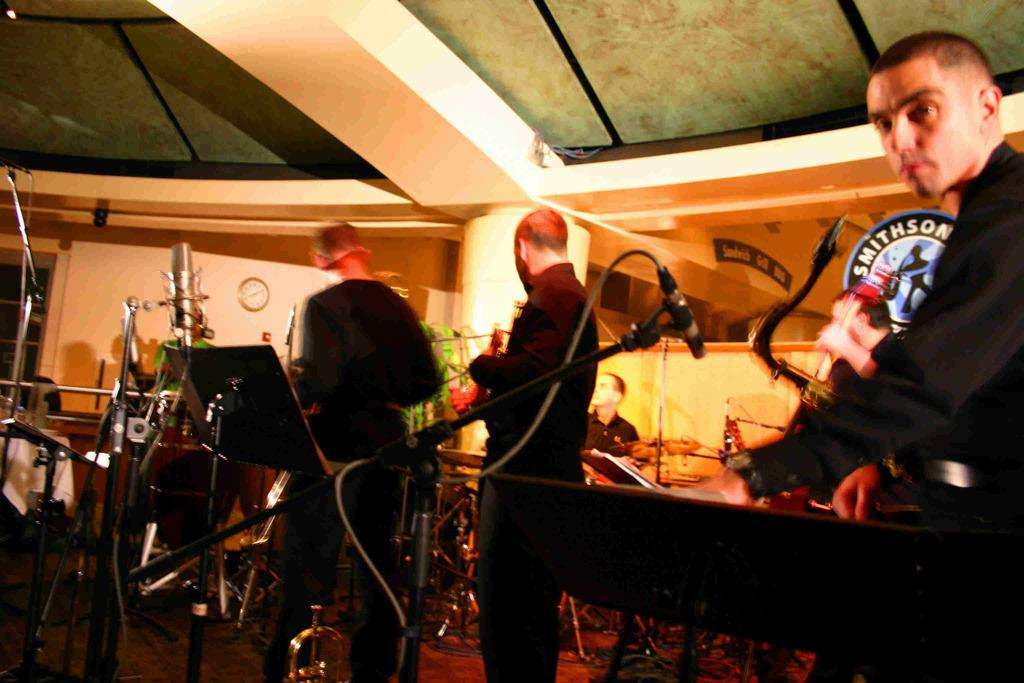What type of structure can be seen in the image? There is a wall in the image. What object is used for measuring time in the image? There is a clock in the image. What device is used for recording audio in the image? There is a mic in the image. Can you describe the people present in the image? There are people present in the image, but their specific characteristics are not mentioned in the provided facts. What type of haircut do the people have in the image? There is no information about the people's haircuts in the provided facts, so we cannot answer this question. What type of volleyball game is being played in the image? There is no mention of a volleyball game or any sports-related activity in the provided facts, so we cannot answer this question. 